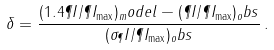Convert formula to latex. <formula><loc_0><loc_0><loc_500><loc_500>\delta = \frac { ( 1 . 4 \P I / \P I _ { \max } ) _ { m } o d e l - ( \P I / \P I _ { \max } ) _ { o } b s } { ( \sigma _ { \P } I / \P I _ { \max } ) _ { o } b s } \, .</formula> 